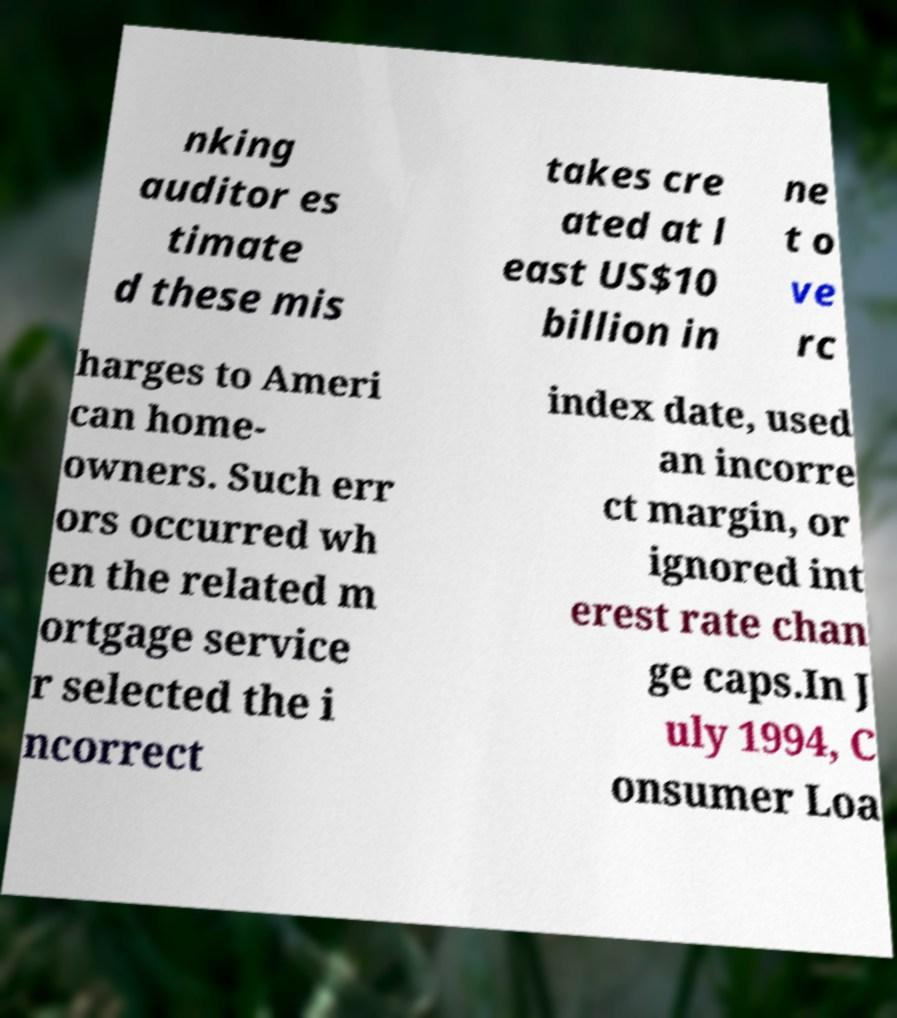What messages or text are displayed in this image? I need them in a readable, typed format. nking auditor es timate d these mis takes cre ated at l east US$10 billion in ne t o ve rc harges to Ameri can home- owners. Such err ors occurred wh en the related m ortgage service r selected the i ncorrect index date, used an incorre ct margin, or ignored int erest rate chan ge caps.In J uly 1994, C onsumer Loa 